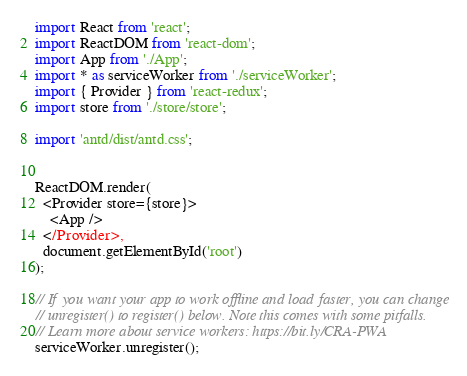<code> <loc_0><loc_0><loc_500><loc_500><_TypeScript_>import React from 'react';
import ReactDOM from 'react-dom';
import App from './App';
import * as serviceWorker from './serviceWorker';
import { Provider } from 'react-redux';
import store from './store/store';

import 'antd/dist/antd.css';


ReactDOM.render(
  <Provider store={store}>
    <App />
  </Provider>,
  document.getElementById('root')
);

// If you want your app to work offline and load faster, you can change
// unregister() to register() below. Note this comes with some pitfalls.
// Learn more about service workers: https://bit.ly/CRA-PWA
serviceWorker.unregister();
</code> 